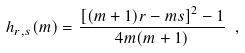Convert formula to latex. <formula><loc_0><loc_0><loc_500><loc_500>h _ { r , s } ( m ) = \frac { \left [ ( m + 1 ) r - m s \right ] ^ { 2 } - 1 } { 4 m ( m + 1 ) } \ ,</formula> 